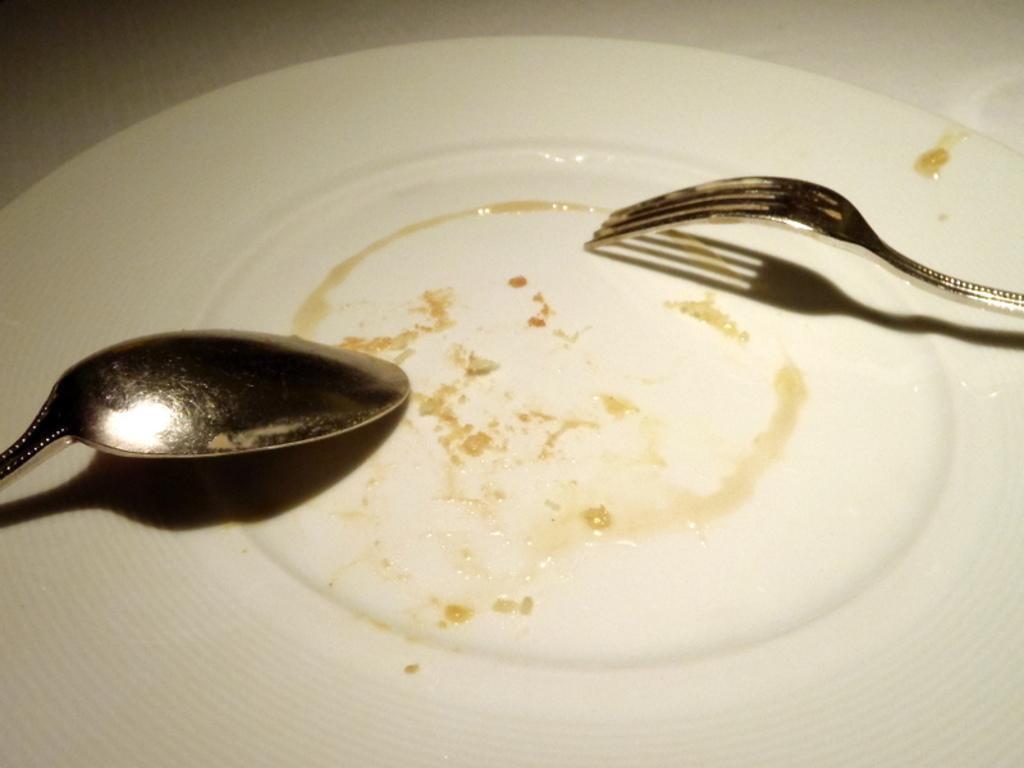In one or two sentences, can you explain what this image depicts? In this image there is a plate and in the plate there is a spoon and one fork, and at the top it looks like a tissue paper. 